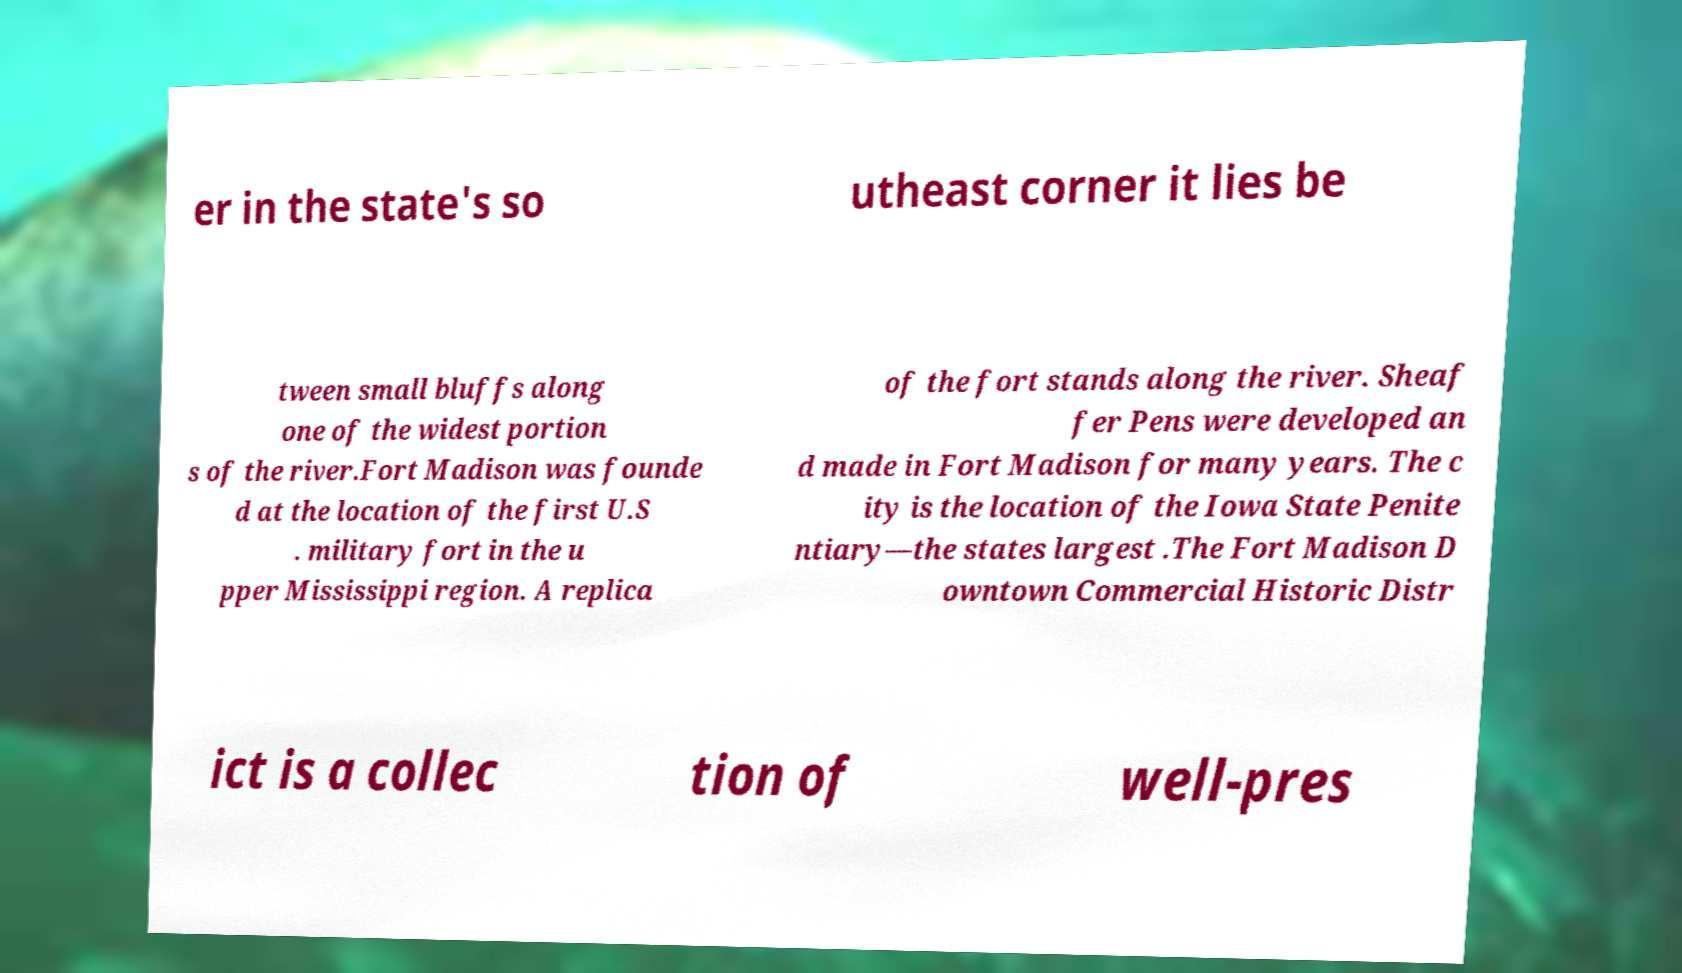What messages or text are displayed in this image? I need them in a readable, typed format. er in the state's so utheast corner it lies be tween small bluffs along one of the widest portion s of the river.Fort Madison was founde d at the location of the first U.S . military fort in the u pper Mississippi region. A replica of the fort stands along the river. Sheaf fer Pens were developed an d made in Fort Madison for many years. The c ity is the location of the Iowa State Penite ntiary—the states largest .The Fort Madison D owntown Commercial Historic Distr ict is a collec tion of well-pres 